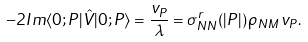Convert formula to latex. <formula><loc_0><loc_0><loc_500><loc_500>- 2 I m \langle 0 ; { P } | \hat { V } | 0 ; { P } \rangle = \frac { v _ { P } } { \lambda } = \sigma _ { N N } ^ { r } ( | { P } | ) \, \rho _ { N M } \, v _ { P } .</formula> 